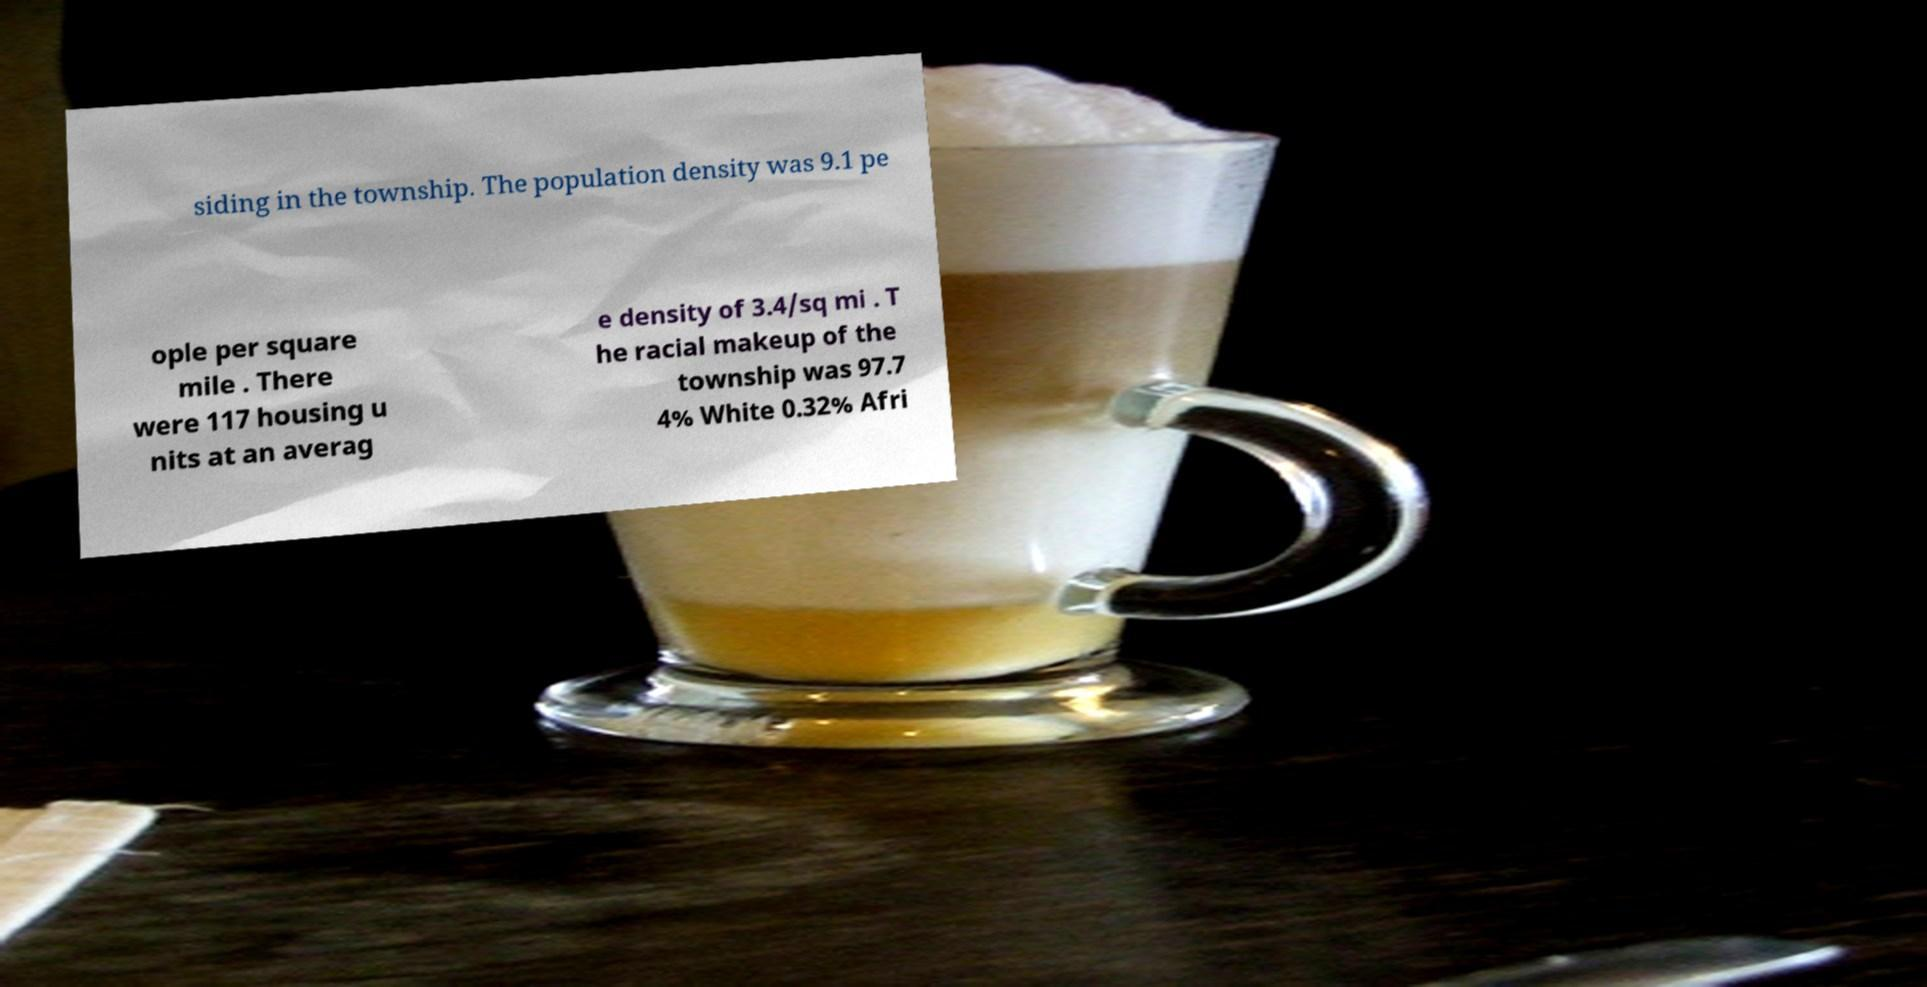Could you extract and type out the text from this image? siding in the township. The population density was 9.1 pe ople per square mile . There were 117 housing u nits at an averag e density of 3.4/sq mi . T he racial makeup of the township was 97.7 4% White 0.32% Afri 